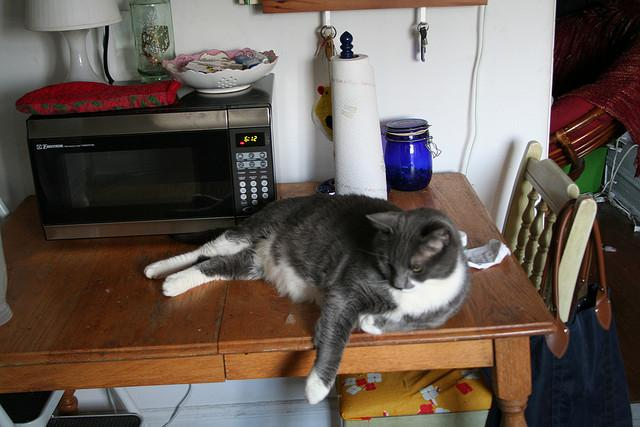What is illuminating the cat and the table? sunlight 